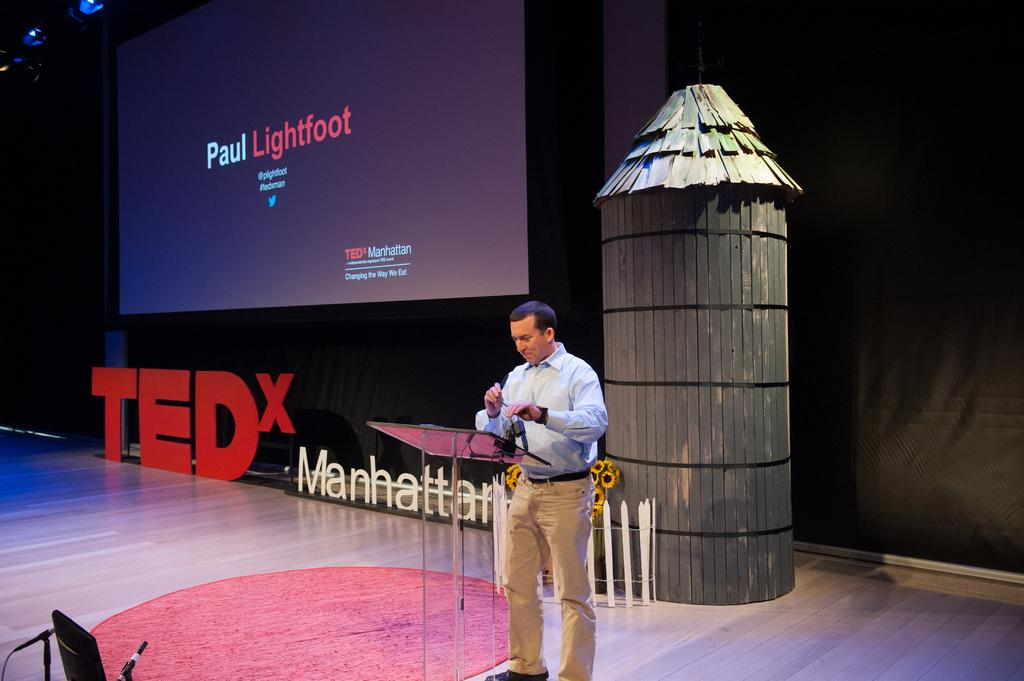Who is present in the image? There is a man in the image. What is the man wearing? The man is wearing a blue shirt. Where is the man located in the image? The man is standing on a stage. What can be seen in the background of the image? There is a projector screen in the background of the image. Can you see a field, carriage, or bridge in the image? No, there is no field, carriage, or bridge present in the image. 